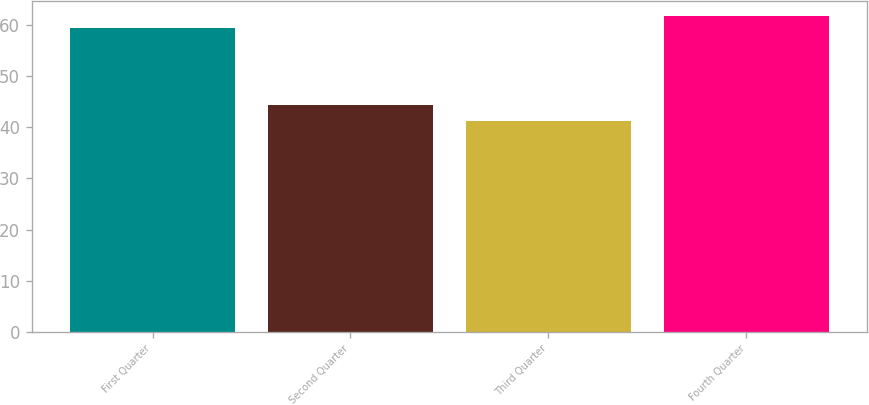Convert chart. <chart><loc_0><loc_0><loc_500><loc_500><bar_chart><fcel>First Quarter<fcel>Second Quarter<fcel>Third Quarter<fcel>Fourth Quarter<nl><fcel>59.47<fcel>44.45<fcel>41.32<fcel>61.74<nl></chart> 